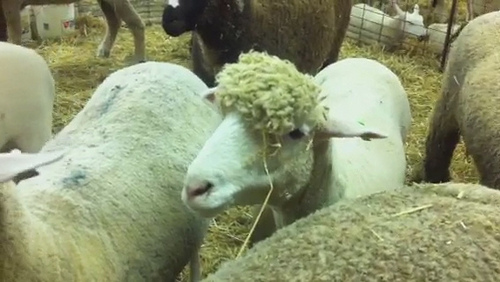The sheep is lying where? The sheep is lying on the grass. 